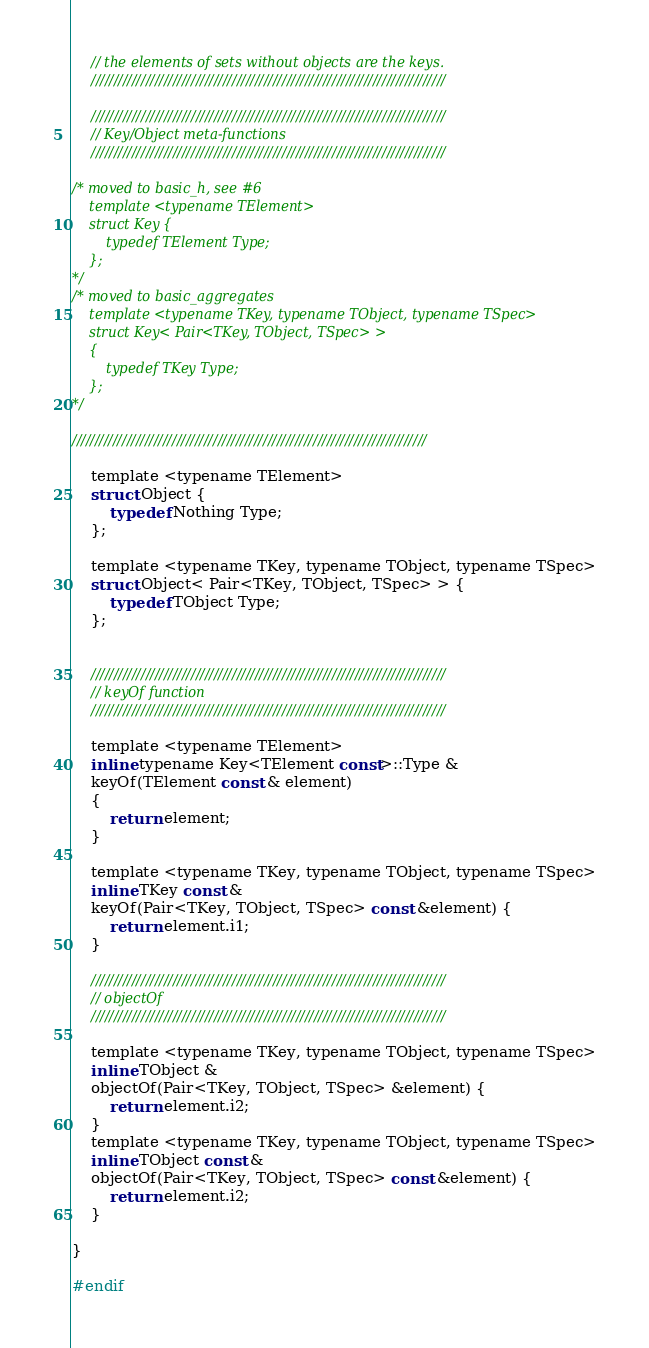<code> <loc_0><loc_0><loc_500><loc_500><_C_>	// the elements of sets without objects are the keys.
	//////////////////////////////////////////////////////////////////////////////

	//////////////////////////////////////////////////////////////////////////////
	// Key/Object meta-functions
	//////////////////////////////////////////////////////////////////////////////

/* moved to basic_h, see #6
	template <typename TElement>
	struct Key {
		typedef TElement Type;
	};
*/
/* moved to basic_aggregates
	template <typename TKey, typename TObject, typename TSpec>
	struct Key< Pair<TKey, TObject, TSpec> > 
	{
		typedef TKey Type;
	};
*/

//////////////////////////////////////////////////////////////////////////////

	template <typename TElement>
	struct Object {
		typedef Nothing Type;
	};

	template <typename TKey, typename TObject, typename TSpec>
	struct Object< Pair<TKey, TObject, TSpec> > {
		typedef TObject Type;
	};


	//////////////////////////////////////////////////////////////////////////////
	// keyOf function
	//////////////////////////////////////////////////////////////////////////////

	template <typename TElement>
	inline typename Key<TElement const>::Type & 
	keyOf(TElement const & element) 
	{
		return element;
	}

	template <typename TKey, typename TObject, typename TSpec>
	inline TKey const &
	keyOf(Pair<TKey, TObject, TSpec> const &element) {
		return element.i1;
	}

	//////////////////////////////////////////////////////////////////////////////
	// objectOf
	//////////////////////////////////////////////////////////////////////////////

	template <typename TKey, typename TObject, typename TSpec>
	inline TObject & 
	objectOf(Pair<TKey, TObject, TSpec> &element) {
		return element.i2;
	}
	template <typename TKey, typename TObject, typename TSpec>
	inline TObject const &
	objectOf(Pair<TKey, TObject, TSpec> const &element) {
		return element.i2;
	}

}

#endif

</code> 